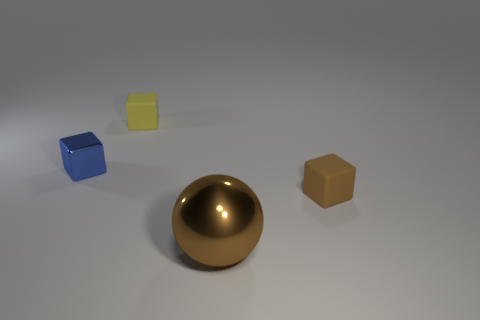Are there any other things that have the same size as the brown ball?
Give a very brief answer. No. Are there fewer metal objects that are on the left side of the metallic ball than tiny things in front of the small yellow rubber cube?
Your answer should be very brief. Yes. There is a thing that is to the left of the tiny matte cube that is behind the metallic block; are there any tiny rubber things that are in front of it?
Provide a short and direct response. Yes. There is a shiny object in front of the blue shiny object; does it have the same shape as the brown matte thing that is right of the brown sphere?
Your answer should be very brief. No. What is the material of the yellow thing that is the same size as the brown rubber cube?
Your answer should be very brief. Rubber. Does the small blue thing that is behind the brown metallic sphere have the same material as the small cube that is behind the small blue cube?
Offer a very short reply. No. How many other things are there of the same color as the big metal thing?
Provide a succinct answer. 1. There is a tiny cube that is on the left side of the yellow thing; what color is it?
Offer a terse response. Blue. How many other objects are there of the same material as the tiny yellow object?
Make the answer very short. 1. Are there more small cubes behind the blue thing than blue metallic objects that are behind the yellow matte block?
Offer a terse response. Yes. 